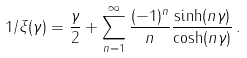Convert formula to latex. <formula><loc_0><loc_0><loc_500><loc_500>1 / \xi ( \gamma ) = \frac { \gamma } { 2 } + \sum _ { n = 1 } ^ { \infty } \frac { ( - 1 ) ^ { n } } { n } \frac { \sinh ( n \gamma ) } { \cosh ( n \gamma ) } \, .</formula> 